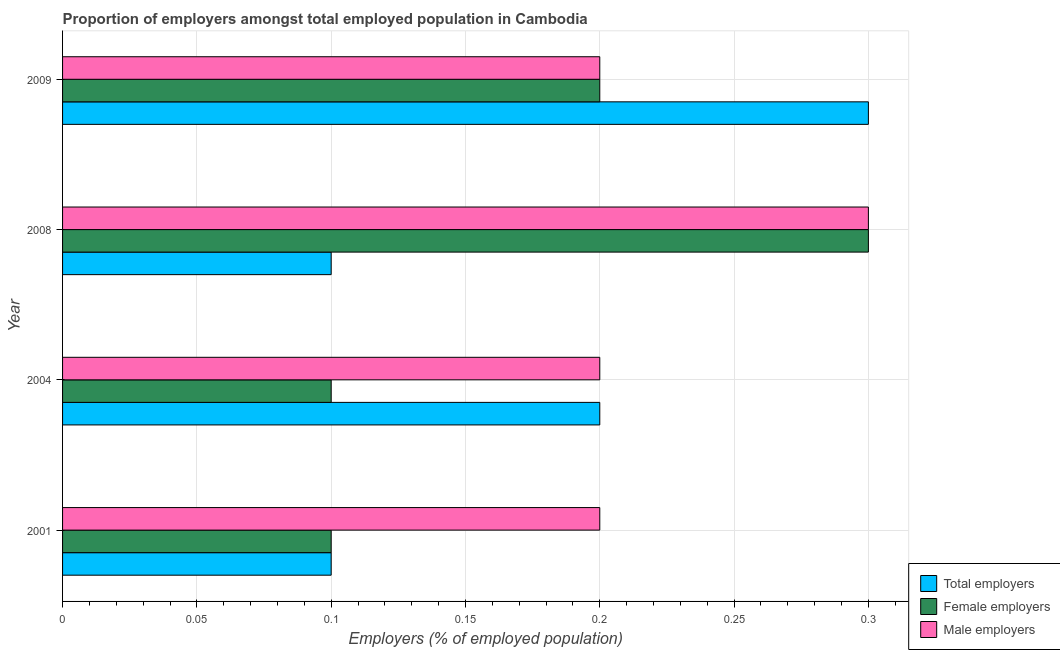Are the number of bars per tick equal to the number of legend labels?
Provide a succinct answer. Yes. Are the number of bars on each tick of the Y-axis equal?
Your response must be concise. Yes. What is the label of the 1st group of bars from the top?
Provide a short and direct response. 2009. In how many cases, is the number of bars for a given year not equal to the number of legend labels?
Provide a succinct answer. 0. What is the percentage of male employers in 2009?
Give a very brief answer. 0.2. Across all years, what is the maximum percentage of male employers?
Ensure brevity in your answer.  0.3. Across all years, what is the minimum percentage of female employers?
Give a very brief answer. 0.1. In which year was the percentage of male employers maximum?
Your answer should be compact. 2008. In which year was the percentage of male employers minimum?
Make the answer very short. 2001. What is the total percentage of total employers in the graph?
Offer a very short reply. 0.7. What is the difference between the percentage of male employers in 2004 and the percentage of total employers in 2009?
Ensure brevity in your answer.  -0.1. What is the average percentage of male employers per year?
Your response must be concise. 0.23. In the year 2008, what is the difference between the percentage of male employers and percentage of female employers?
Provide a succinct answer. 0. In how many years, is the percentage of total employers greater than 0.29 %?
Offer a very short reply. 1. What is the ratio of the percentage of female employers in 2001 to that in 2009?
Your answer should be compact. 0.5. Is the percentage of total employers in 2001 less than that in 2004?
Your response must be concise. Yes. Is the difference between the percentage of female employers in 2001 and 2004 greater than the difference between the percentage of male employers in 2001 and 2004?
Keep it short and to the point. No. What is the difference between the highest and the second highest percentage of female employers?
Make the answer very short. 0.1. Is the sum of the percentage of female employers in 2001 and 2004 greater than the maximum percentage of male employers across all years?
Offer a very short reply. No. What does the 1st bar from the top in 2009 represents?
Your answer should be very brief. Male employers. What does the 1st bar from the bottom in 2004 represents?
Provide a succinct answer. Total employers. How many bars are there?
Your answer should be very brief. 12. Are all the bars in the graph horizontal?
Your answer should be very brief. Yes. How many years are there in the graph?
Make the answer very short. 4. What is the difference between two consecutive major ticks on the X-axis?
Provide a succinct answer. 0.05. Are the values on the major ticks of X-axis written in scientific E-notation?
Provide a short and direct response. No. Does the graph contain any zero values?
Ensure brevity in your answer.  No. Where does the legend appear in the graph?
Make the answer very short. Bottom right. How are the legend labels stacked?
Your response must be concise. Vertical. What is the title of the graph?
Offer a terse response. Proportion of employers amongst total employed population in Cambodia. What is the label or title of the X-axis?
Offer a very short reply. Employers (% of employed population). What is the Employers (% of employed population) of Total employers in 2001?
Provide a succinct answer. 0.1. What is the Employers (% of employed population) of Female employers in 2001?
Offer a very short reply. 0.1. What is the Employers (% of employed population) in Male employers in 2001?
Offer a terse response. 0.2. What is the Employers (% of employed population) of Total employers in 2004?
Make the answer very short. 0.2. What is the Employers (% of employed population) of Female employers in 2004?
Provide a succinct answer. 0.1. What is the Employers (% of employed population) in Male employers in 2004?
Make the answer very short. 0.2. What is the Employers (% of employed population) of Total employers in 2008?
Provide a short and direct response. 0.1. What is the Employers (% of employed population) of Female employers in 2008?
Provide a short and direct response. 0.3. What is the Employers (% of employed population) in Male employers in 2008?
Provide a short and direct response. 0.3. What is the Employers (% of employed population) of Total employers in 2009?
Offer a terse response. 0.3. What is the Employers (% of employed population) in Female employers in 2009?
Keep it short and to the point. 0.2. What is the Employers (% of employed population) of Male employers in 2009?
Your response must be concise. 0.2. Across all years, what is the maximum Employers (% of employed population) of Total employers?
Provide a short and direct response. 0.3. Across all years, what is the maximum Employers (% of employed population) of Female employers?
Your answer should be very brief. 0.3. Across all years, what is the maximum Employers (% of employed population) of Male employers?
Ensure brevity in your answer.  0.3. Across all years, what is the minimum Employers (% of employed population) in Total employers?
Provide a succinct answer. 0.1. Across all years, what is the minimum Employers (% of employed population) of Female employers?
Offer a terse response. 0.1. Across all years, what is the minimum Employers (% of employed population) in Male employers?
Make the answer very short. 0.2. What is the total Employers (% of employed population) in Female employers in the graph?
Your answer should be compact. 0.7. What is the total Employers (% of employed population) of Male employers in the graph?
Offer a very short reply. 0.9. What is the difference between the Employers (% of employed population) in Total employers in 2001 and that in 2004?
Your answer should be very brief. -0.1. What is the difference between the Employers (% of employed population) of Male employers in 2001 and that in 2008?
Make the answer very short. -0.1. What is the difference between the Employers (% of employed population) in Total employers in 2004 and that in 2008?
Make the answer very short. 0.1. What is the difference between the Employers (% of employed population) of Female employers in 2004 and that in 2008?
Provide a short and direct response. -0.2. What is the difference between the Employers (% of employed population) in Female employers in 2004 and that in 2009?
Make the answer very short. -0.1. What is the difference between the Employers (% of employed population) in Male employers in 2008 and that in 2009?
Offer a very short reply. 0.1. What is the difference between the Employers (% of employed population) of Total employers in 2001 and the Employers (% of employed population) of Female employers in 2004?
Ensure brevity in your answer.  0. What is the difference between the Employers (% of employed population) of Total employers in 2001 and the Employers (% of employed population) of Female employers in 2008?
Offer a terse response. -0.2. What is the difference between the Employers (% of employed population) in Female employers in 2001 and the Employers (% of employed population) in Male employers in 2008?
Provide a succinct answer. -0.2. What is the difference between the Employers (% of employed population) of Total employers in 2001 and the Employers (% of employed population) of Female employers in 2009?
Offer a very short reply. -0.1. What is the difference between the Employers (% of employed population) in Total employers in 2001 and the Employers (% of employed population) in Male employers in 2009?
Give a very brief answer. -0.1. What is the difference between the Employers (% of employed population) in Total employers in 2004 and the Employers (% of employed population) in Male employers in 2008?
Offer a terse response. -0.1. What is the difference between the Employers (% of employed population) of Female employers in 2004 and the Employers (% of employed population) of Male employers in 2008?
Offer a terse response. -0.2. What is the difference between the Employers (% of employed population) in Female employers in 2004 and the Employers (% of employed population) in Male employers in 2009?
Give a very brief answer. -0.1. What is the difference between the Employers (% of employed population) in Total employers in 2008 and the Employers (% of employed population) in Male employers in 2009?
Provide a short and direct response. -0.1. What is the difference between the Employers (% of employed population) in Female employers in 2008 and the Employers (% of employed population) in Male employers in 2009?
Give a very brief answer. 0.1. What is the average Employers (% of employed population) in Total employers per year?
Your response must be concise. 0.17. What is the average Employers (% of employed population) in Female employers per year?
Your answer should be very brief. 0.17. What is the average Employers (% of employed population) of Male employers per year?
Keep it short and to the point. 0.23. In the year 2001, what is the difference between the Employers (% of employed population) in Total employers and Employers (% of employed population) in Female employers?
Offer a very short reply. 0. In the year 2001, what is the difference between the Employers (% of employed population) of Female employers and Employers (% of employed population) of Male employers?
Your answer should be very brief. -0.1. In the year 2004, what is the difference between the Employers (% of employed population) in Total employers and Employers (% of employed population) in Male employers?
Give a very brief answer. 0. In the year 2004, what is the difference between the Employers (% of employed population) in Female employers and Employers (% of employed population) in Male employers?
Offer a very short reply. -0.1. In the year 2008, what is the difference between the Employers (% of employed population) in Total employers and Employers (% of employed population) in Male employers?
Give a very brief answer. -0.2. In the year 2008, what is the difference between the Employers (% of employed population) in Female employers and Employers (% of employed population) in Male employers?
Provide a succinct answer. 0. In the year 2009, what is the difference between the Employers (% of employed population) in Total employers and Employers (% of employed population) in Female employers?
Keep it short and to the point. 0.1. What is the ratio of the Employers (% of employed population) of Female employers in 2001 to that in 2004?
Your answer should be compact. 1. What is the ratio of the Employers (% of employed population) of Male employers in 2001 to that in 2004?
Offer a terse response. 1. What is the ratio of the Employers (% of employed population) of Total employers in 2001 to that in 2008?
Ensure brevity in your answer.  1. What is the ratio of the Employers (% of employed population) in Female employers in 2004 to that in 2008?
Your response must be concise. 0.33. What is the ratio of the Employers (% of employed population) of Female employers in 2004 to that in 2009?
Ensure brevity in your answer.  0.5. What is the ratio of the Employers (% of employed population) in Male employers in 2004 to that in 2009?
Make the answer very short. 1. What is the ratio of the Employers (% of employed population) of Total employers in 2008 to that in 2009?
Give a very brief answer. 0.33. What is the ratio of the Employers (% of employed population) of Male employers in 2008 to that in 2009?
Offer a terse response. 1.5. What is the difference between the highest and the second highest Employers (% of employed population) of Total employers?
Offer a terse response. 0.1. What is the difference between the highest and the second highest Employers (% of employed population) of Male employers?
Your response must be concise. 0.1. What is the difference between the highest and the lowest Employers (% of employed population) of Total employers?
Give a very brief answer. 0.2. What is the difference between the highest and the lowest Employers (% of employed population) of Female employers?
Ensure brevity in your answer.  0.2. What is the difference between the highest and the lowest Employers (% of employed population) of Male employers?
Your answer should be compact. 0.1. 